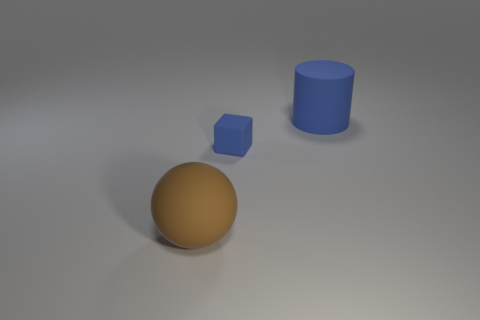Add 3 large brown matte spheres. How many objects exist? 6 Subtract all balls. How many objects are left? 2 Add 3 cubes. How many cubes are left? 4 Add 2 matte objects. How many matte objects exist? 5 Subtract 0 purple cylinders. How many objects are left? 3 Subtract all tiny gray metallic cubes. Subtract all brown objects. How many objects are left? 2 